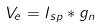Convert formula to latex. <formula><loc_0><loc_0><loc_500><loc_500>V _ { e } = I _ { s p } * g _ { n }</formula> 